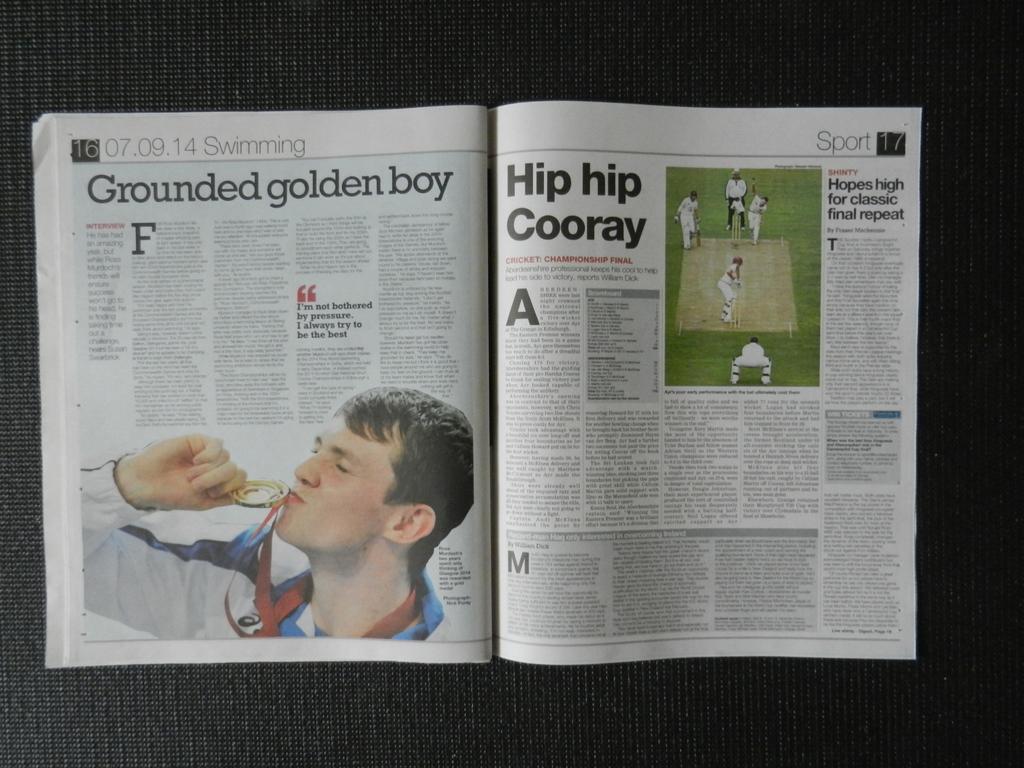How would you summarize this image in a sentence or two? In this image, we can see a magazine. 